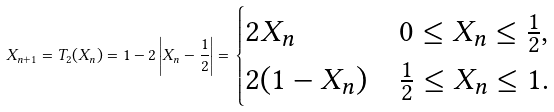Convert formula to latex. <formula><loc_0><loc_0><loc_500><loc_500>X _ { n + 1 } = T _ { 2 } ( X _ { n } ) = 1 - 2 \left | X _ { n } - \frac { 1 } { 2 } \right | = \begin{cases} 2 X _ { n } & 0 \leq X _ { n } \leq \frac { 1 } { 2 } , \\ 2 ( 1 - X _ { n } ) & \frac { 1 } { 2 } \leq X _ { n } \leq 1 . \end{cases}</formula> 